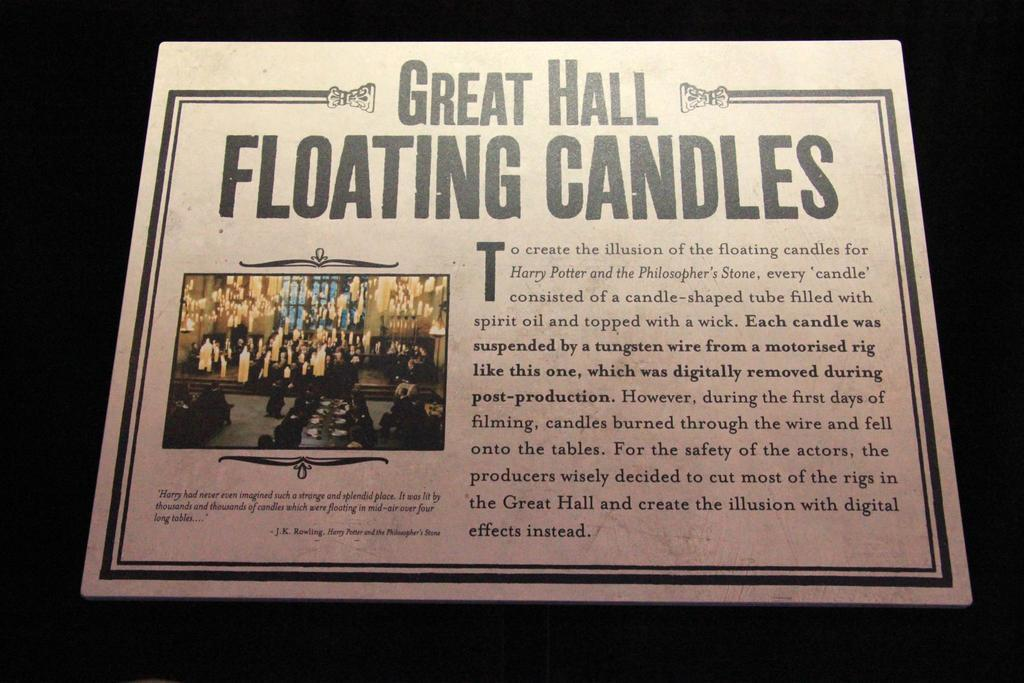<image>
Relay a brief, clear account of the picture shown. A cardboard card filled with information regarding the filming of the first Harry Potter Film 